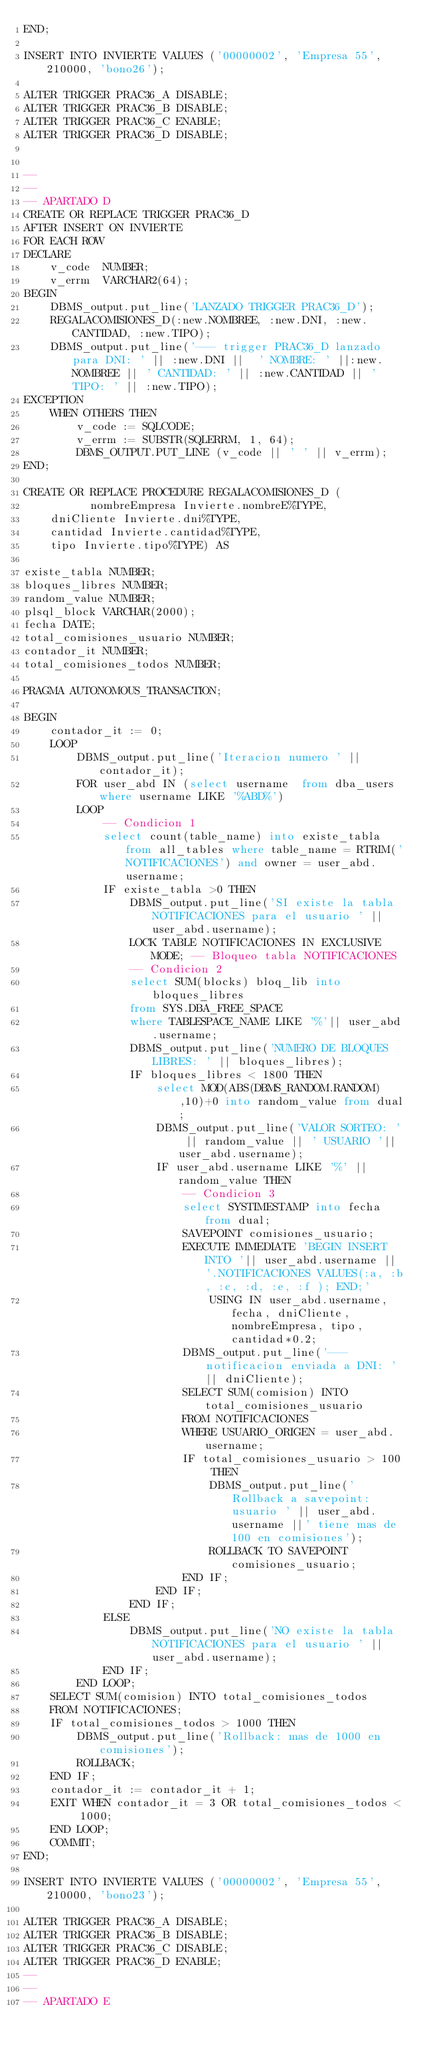<code> <loc_0><loc_0><loc_500><loc_500><_SQL_>END;

INSERT INTO INVIERTE VALUES ('00000002', 'Empresa 55', 210000, 'bono26');

ALTER TRIGGER PRAC36_A DISABLE;
ALTER TRIGGER PRAC36_B DISABLE;
ALTER TRIGGER PRAC36_C ENABLE;
ALTER TRIGGER PRAC36_D DISABLE;


--
--
-- APARTADO D
CREATE OR REPLACE TRIGGER PRAC36_D
AFTER INSERT ON INVIERTE
FOR EACH ROW
DECLARE
    v_code  NUMBER;
    v_errm  VARCHAR2(64);
BEGIN 
    DBMS_output.put_line('LANZADO TRIGGER PRAC36_D');
    REGALACOMISIONES_D(:new.NOMBREE, :new.DNI, :new.CANTIDAD, :new.TIPO);
    DBMS_output.put_line('--- trigger PRAC36_D lanzado para DNI: ' || :new.DNI ||  ' NOMBRE: ' ||:new.NOMBREE || ' CANTIDAD: ' || :new.CANTIDAD || ' TIPO: ' || :new.TIPO);
EXCEPTION
    WHEN OTHERS THEN
        v_code := SQLCODE;
        v_errm := SUBSTR(SQLERRM, 1, 64);
        DBMS_OUTPUT.PUT_LINE (v_code || ' ' || v_errm);
END;

CREATE OR REPLACE PROCEDURE REGALACOMISIONES_D (
       	  nombreEmpresa Invierte.nombreE%TYPE,
	  dniCliente Invierte.dni%TYPE,
	  cantidad Invierte.cantidad%TYPE,
	  tipo Invierte.tipo%TYPE) AS
      
existe_tabla NUMBER;
bloques_libres NUMBER;
random_value NUMBER;
plsql_block VARCHAR(2000);
fecha DATE;
total_comisiones_usuario NUMBER;
contador_it NUMBER;
total_comisiones_todos NUMBER;

PRAGMA AUTONOMOUS_TRANSACTION;

BEGIN
    contador_it := 0;
    LOOP
        DBMS_output.put_line('Iteracion numero ' || contador_it);
        FOR user_abd IN (select username  from dba_users where username LIKE '%ABD%')
        LOOP
            -- Condicion 1
            select count(table_name) into existe_tabla from all_tables where table_name = RTRIM('NOTIFICACIONES') and owner = user_abd.username;
            IF existe_tabla >0 THEN
                DBMS_output.put_line('SI existe la tabla NOTIFICACIONES para el usuario ' || user_abd.username);
                LOCK TABLE NOTIFICACIONES IN EXCLUSIVE MODE; -- Bloqueo tabla NOTIFICACIONES
                -- Condicion 2
                select SUM(blocks) bloq_lib into bloques_libres
                from SYS.DBA_FREE_SPACE
                where TABLESPACE_NAME LIKE '%'|| user_abd.username;
                DBMS_output.put_line('NUMERO DE BLOQUES LIBRES: ' || bloques_libres);
                IF bloques_libres < 1800 THEN
                    select MOD(ABS(DBMS_RANDOM.RANDOM),10)+0 into random_value from dual;
                    DBMS_output.put_line('VALOR SORTEO: ' || random_value || ' USUARIO '|| user_abd.username);
                    IF user_abd.username LIKE '%' || random_value THEN
                        -- Condicion 3
                        select SYSTIMESTAMP into fecha from dual;
                        SAVEPOINT comisiones_usuario;
                        EXECUTE IMMEDIATE 'BEGIN INSERT INTO '|| user_abd.username || '.NOTIFICACIONES VALUES(:a, :b, :c, :d, :e, :f ); END;'
                            USING IN user_abd.username, fecha, dniCliente, nombreEmpresa, tipo, cantidad*0.2;
                        DBMS_output.put_line('--- notificacion enviada a DNI: ' || dniCliente);
                        SELECT SUM(comision) INTO total_comisiones_usuario
                        FROM NOTIFICACIONES
                        WHERE USUARIO_ORIGEN = user_abd.username;
                        IF total_comisiones_usuario > 100 THEN
                            DBMS_output.put_line('Rollback a savepoint: usuario ' || user_abd.username ||' tiene mas de 100 en comisiones');
                            ROLLBACK TO SAVEPOINT comisiones_usuario;
                        END IF;
                    END IF;
                END IF;
            ELSE
                DBMS_output.put_line('NO existe la tabla NOTIFICACIONES para el usuario ' || user_abd.username);
            END IF;
        END LOOP;
    SELECT SUM(comision) INTO total_comisiones_todos
    FROM NOTIFICACIONES;
    IF total_comisiones_todos > 1000 THEN
        DBMS_output.put_line('Rollback: mas de 1000 en comisiones');
        ROLLBACK;
    END IF;
    contador_it := contador_it + 1;
    EXIT WHEN contador_it = 3 OR total_comisiones_todos < 1000;
    END LOOP;
    COMMIT;
END;

INSERT INTO INVIERTE VALUES ('00000002', 'Empresa 55', 210000, 'bono23');

ALTER TRIGGER PRAC36_A DISABLE;
ALTER TRIGGER PRAC36_B DISABLE;
ALTER TRIGGER PRAC36_C DISABLE;
ALTER TRIGGER PRAC36_D ENABLE;
--
--
-- APARTADO E

</code> 